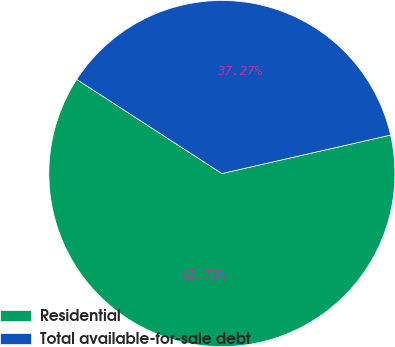<chart> <loc_0><loc_0><loc_500><loc_500><pie_chart><fcel>Residential<fcel>Total available-for-sale debt<nl><fcel>62.73%<fcel>37.27%<nl></chart> 